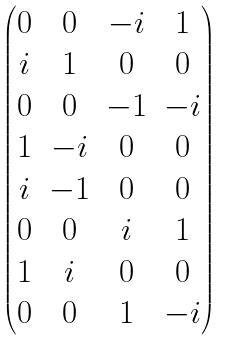Convert formula to latex. <formula><loc_0><loc_0><loc_500><loc_500>\begin{pmatrix} 0 & 0 & - i & 1 \\ i & 1 & 0 & 0 \\ 0 & 0 & - 1 & - i \\ 1 & - i & 0 & 0 \\ i & - 1 & 0 & 0 \\ 0 & 0 & i & 1 \\ 1 & i & 0 & 0 \\ 0 & 0 & 1 & - i \end{pmatrix}</formula> 